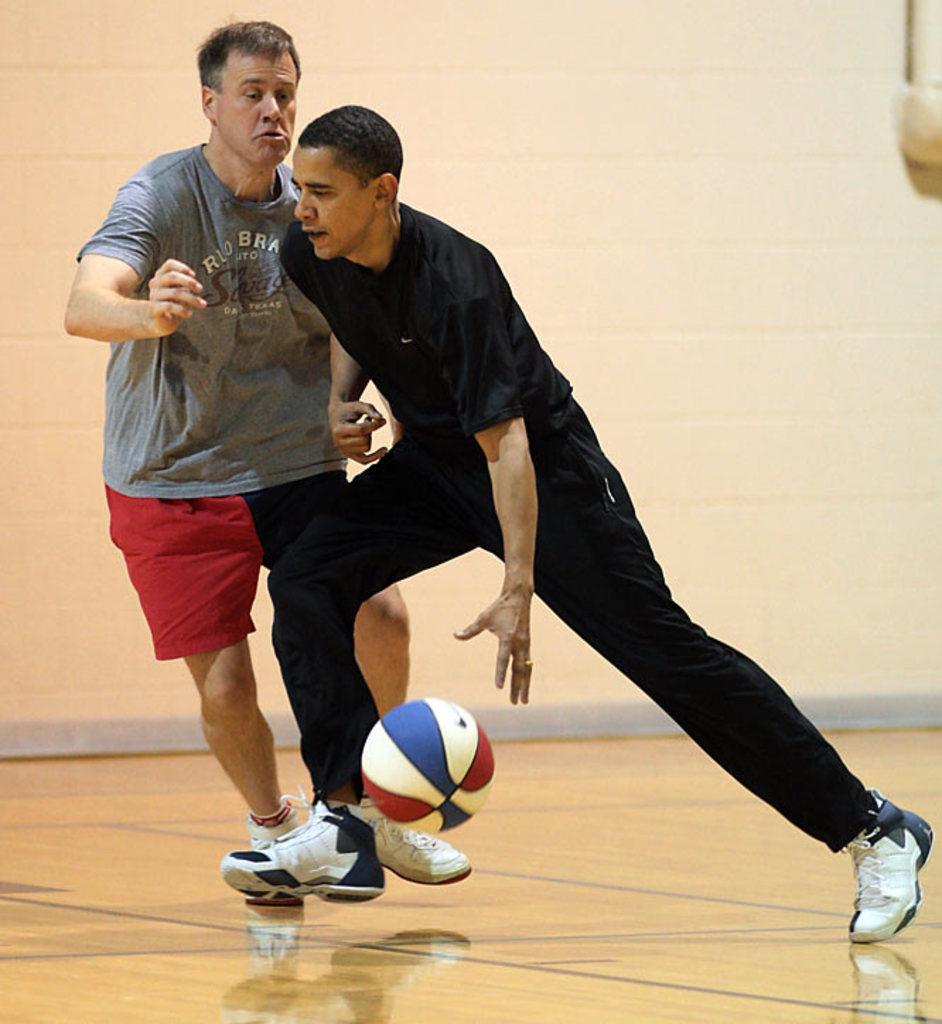What is the main action being performed by the man in the image? The man is running in the image. What is the man trying to do while running? The man is trying to catch a ball. Is there anyone else running in the image? Yes, there is another man running beside him. What can be seen in the background of the image? There is a wall in the background of the image. What type of goose is being held by the man's owner in the image? There is no goose or owner present in the image; it features a man running to catch a ball. What type of basketball is being used in the image? There is no basketball present in the image; it only shows a man running to catch a ball. 